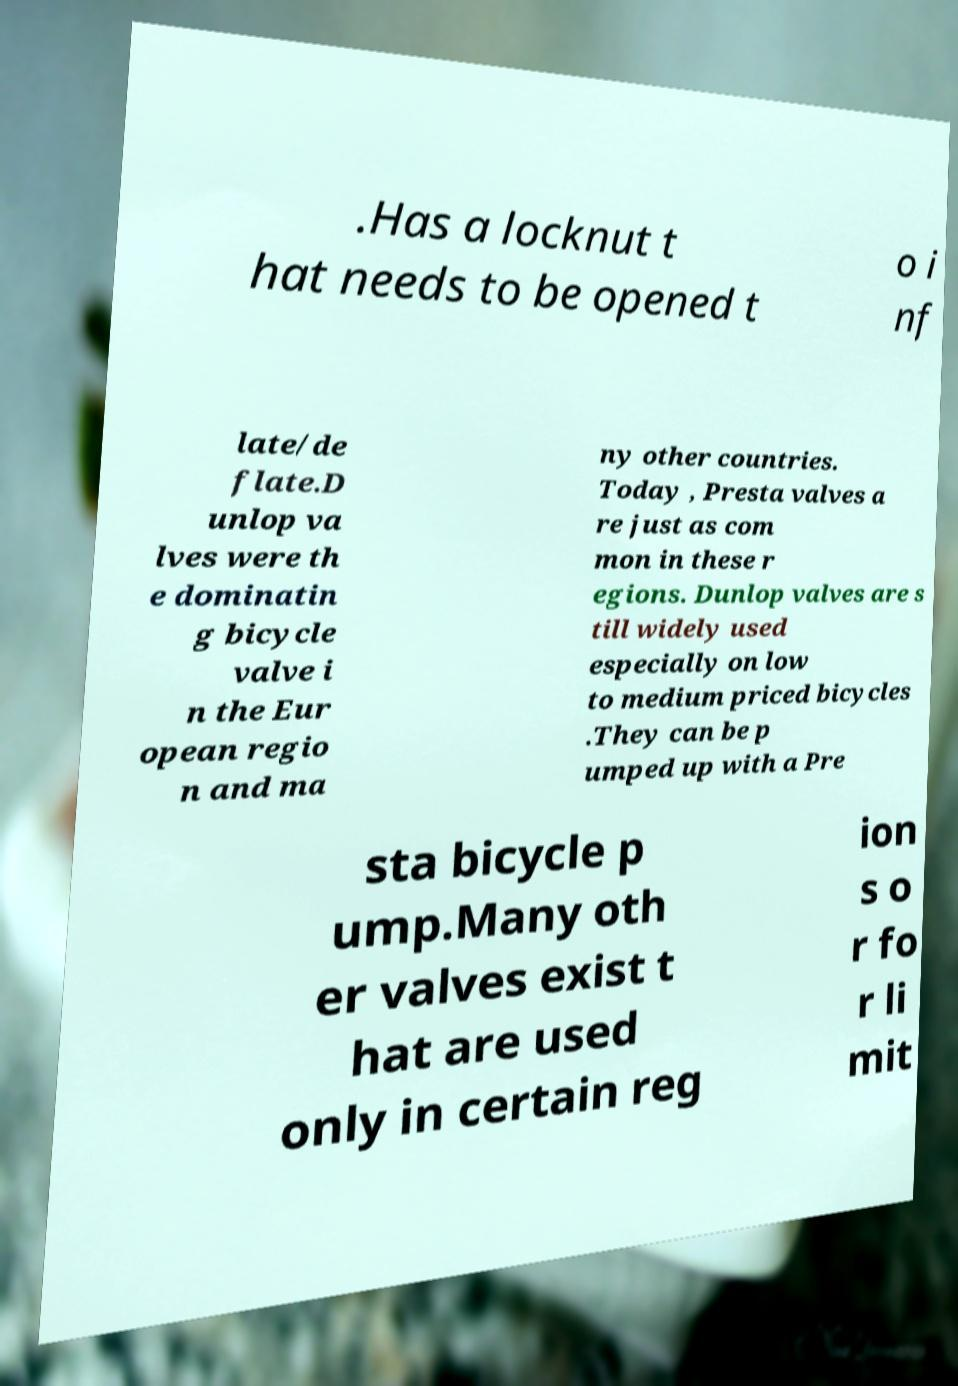Please read and relay the text visible in this image. What does it say? .Has a locknut t hat needs to be opened t o i nf late/de flate.D unlop va lves were th e dominatin g bicycle valve i n the Eur opean regio n and ma ny other countries. Today , Presta valves a re just as com mon in these r egions. Dunlop valves are s till widely used especially on low to medium priced bicycles .They can be p umped up with a Pre sta bicycle p ump.Many oth er valves exist t hat are used only in certain reg ion s o r fo r li mit 